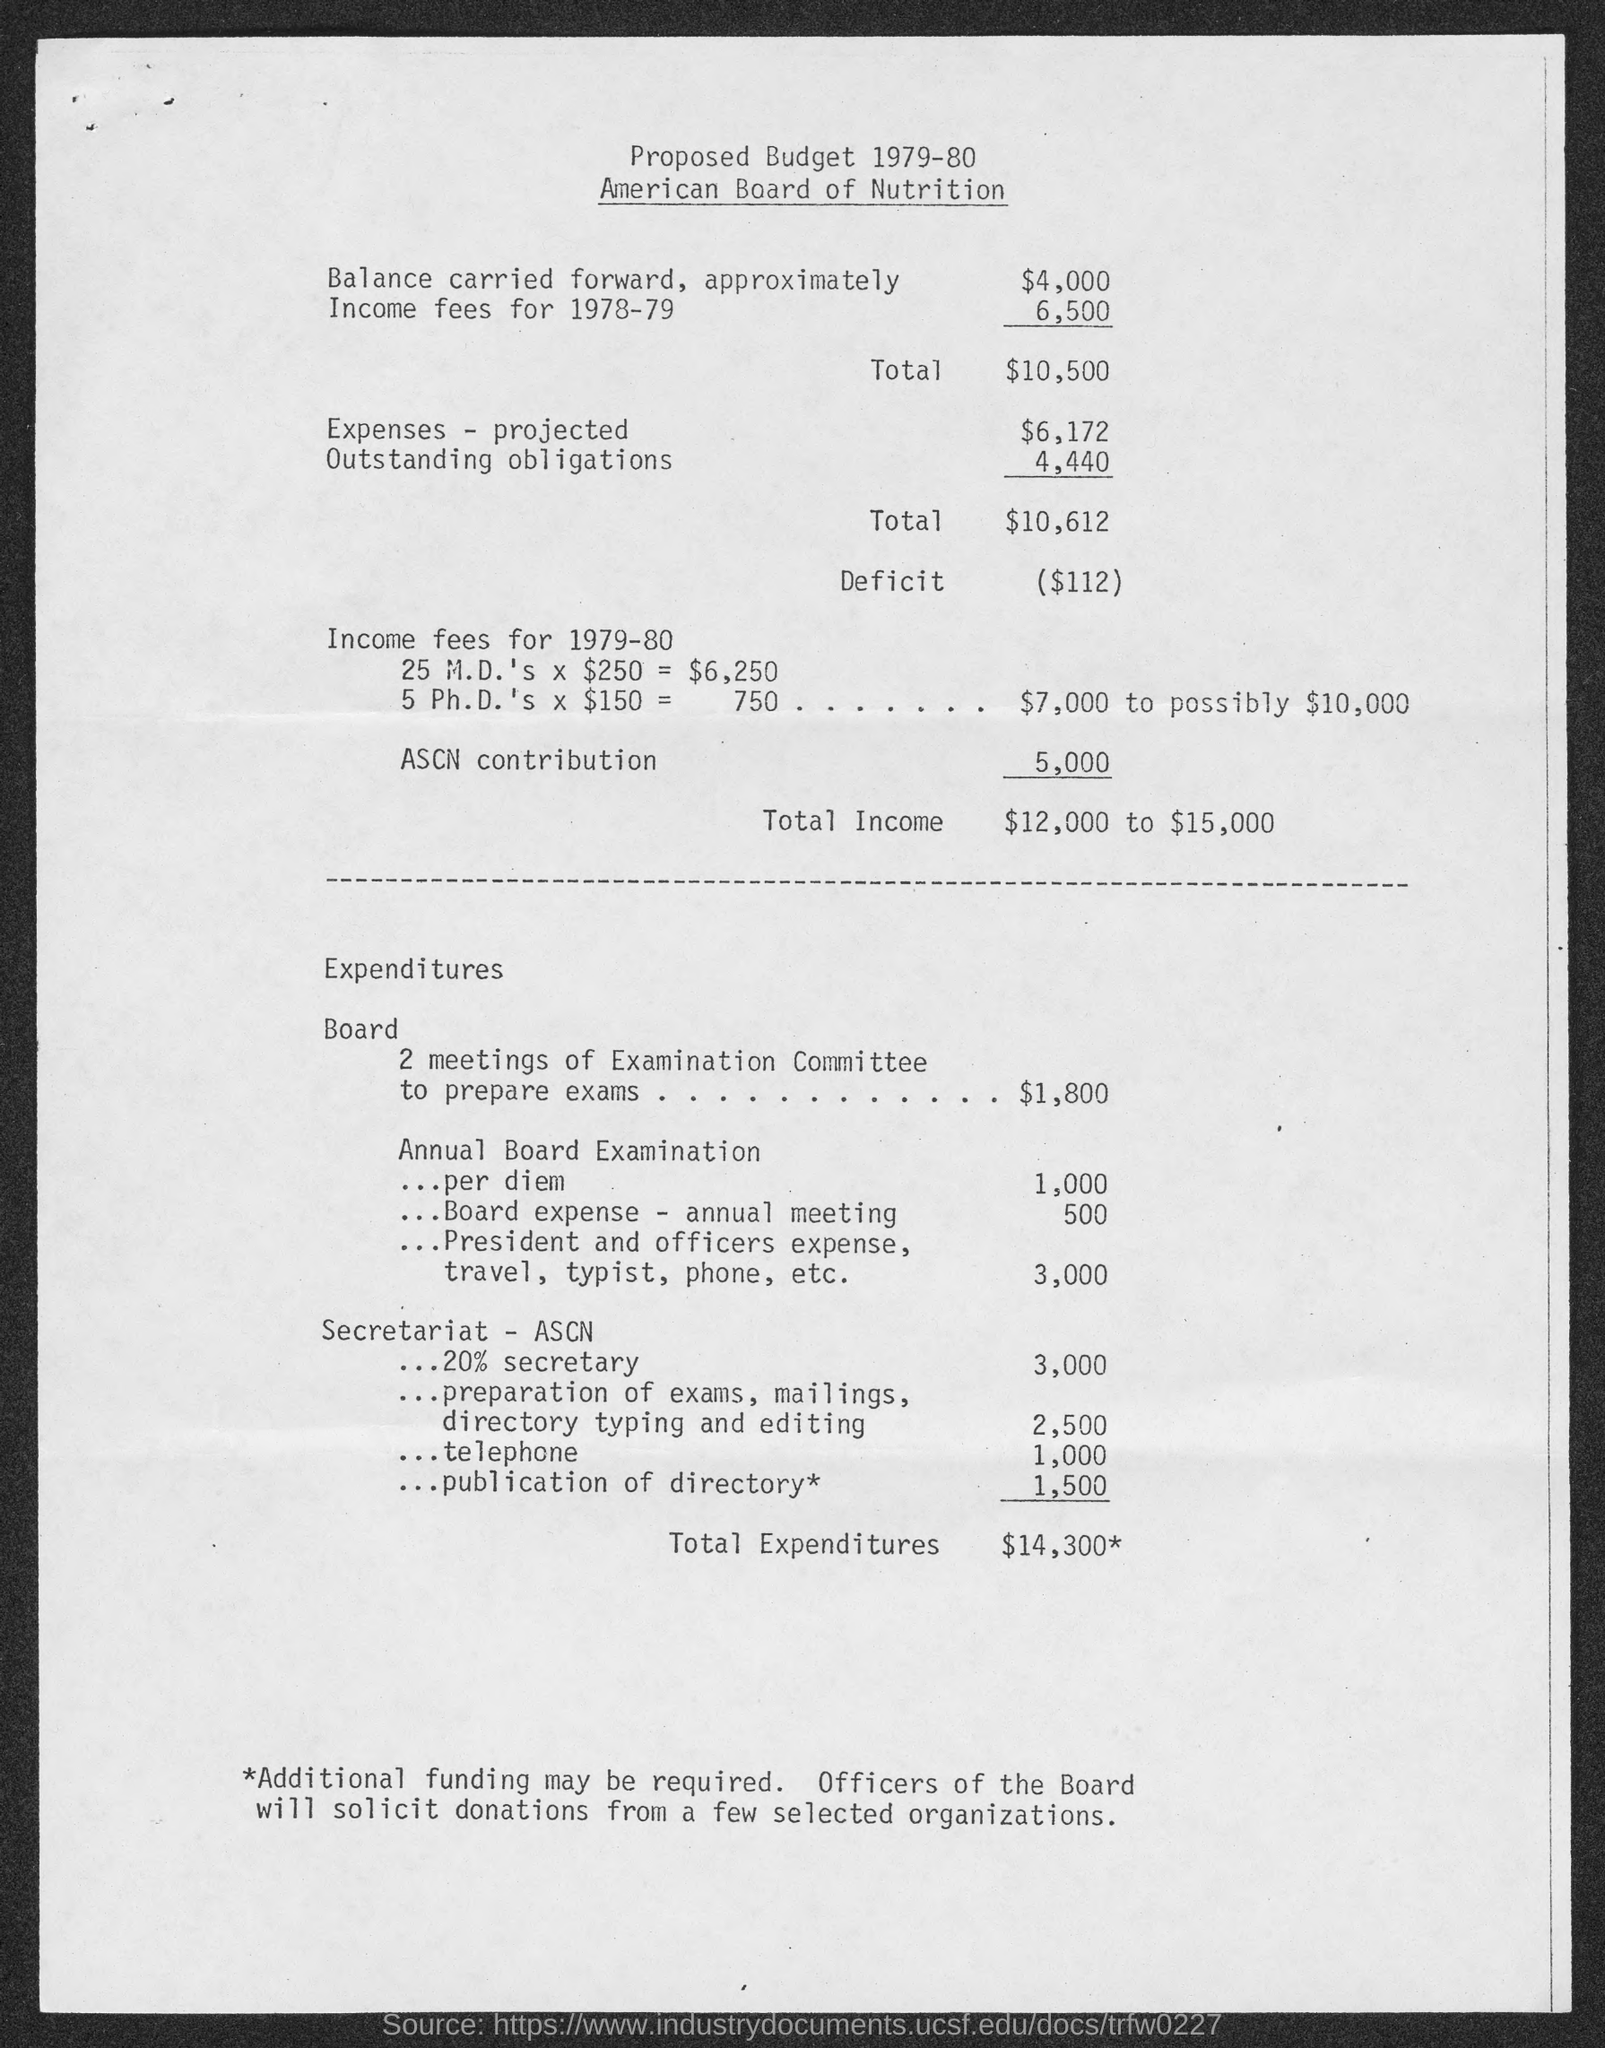How much Total Income ?
Your answer should be compact. $12,000 to $15,000. How much total Expenditures ?
Make the answer very short. 14,300. 